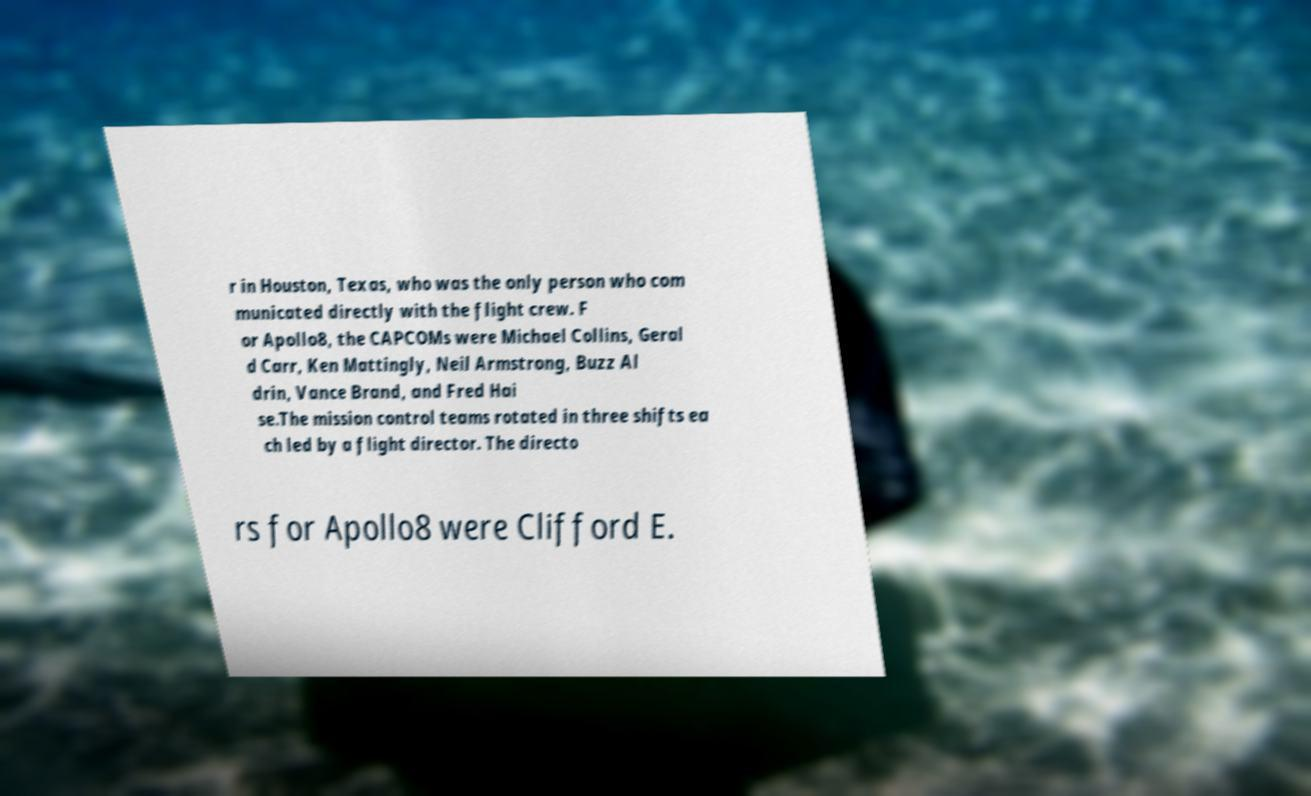For documentation purposes, I need the text within this image transcribed. Could you provide that? r in Houston, Texas, who was the only person who com municated directly with the flight crew. F or Apollo8, the CAPCOMs were Michael Collins, Geral d Carr, Ken Mattingly, Neil Armstrong, Buzz Al drin, Vance Brand, and Fred Hai se.The mission control teams rotated in three shifts ea ch led by a flight director. The directo rs for Apollo8 were Clifford E. 